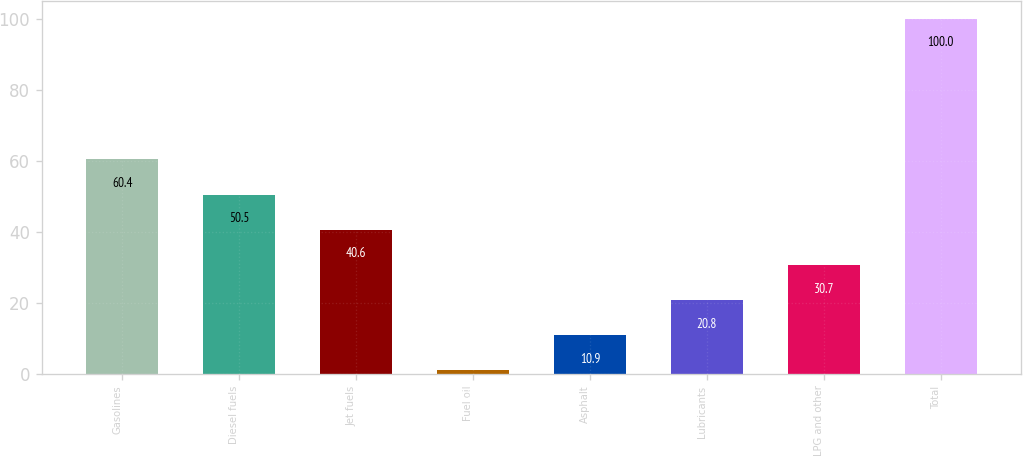<chart> <loc_0><loc_0><loc_500><loc_500><bar_chart><fcel>Gasolines<fcel>Diesel fuels<fcel>Jet fuels<fcel>Fuel oil<fcel>Asphalt<fcel>Lubricants<fcel>LPG and other<fcel>Total<nl><fcel>60.4<fcel>50.5<fcel>40.6<fcel>1<fcel>10.9<fcel>20.8<fcel>30.7<fcel>100<nl></chart> 